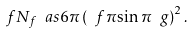Convert formula to latex. <formula><loc_0><loc_0><loc_500><loc_500>\ f { N _ { f } \ a s } { 6 \pi } \left ( \ f { \pi } { \sin \pi \ g } \right ) ^ { 2 } .</formula> 